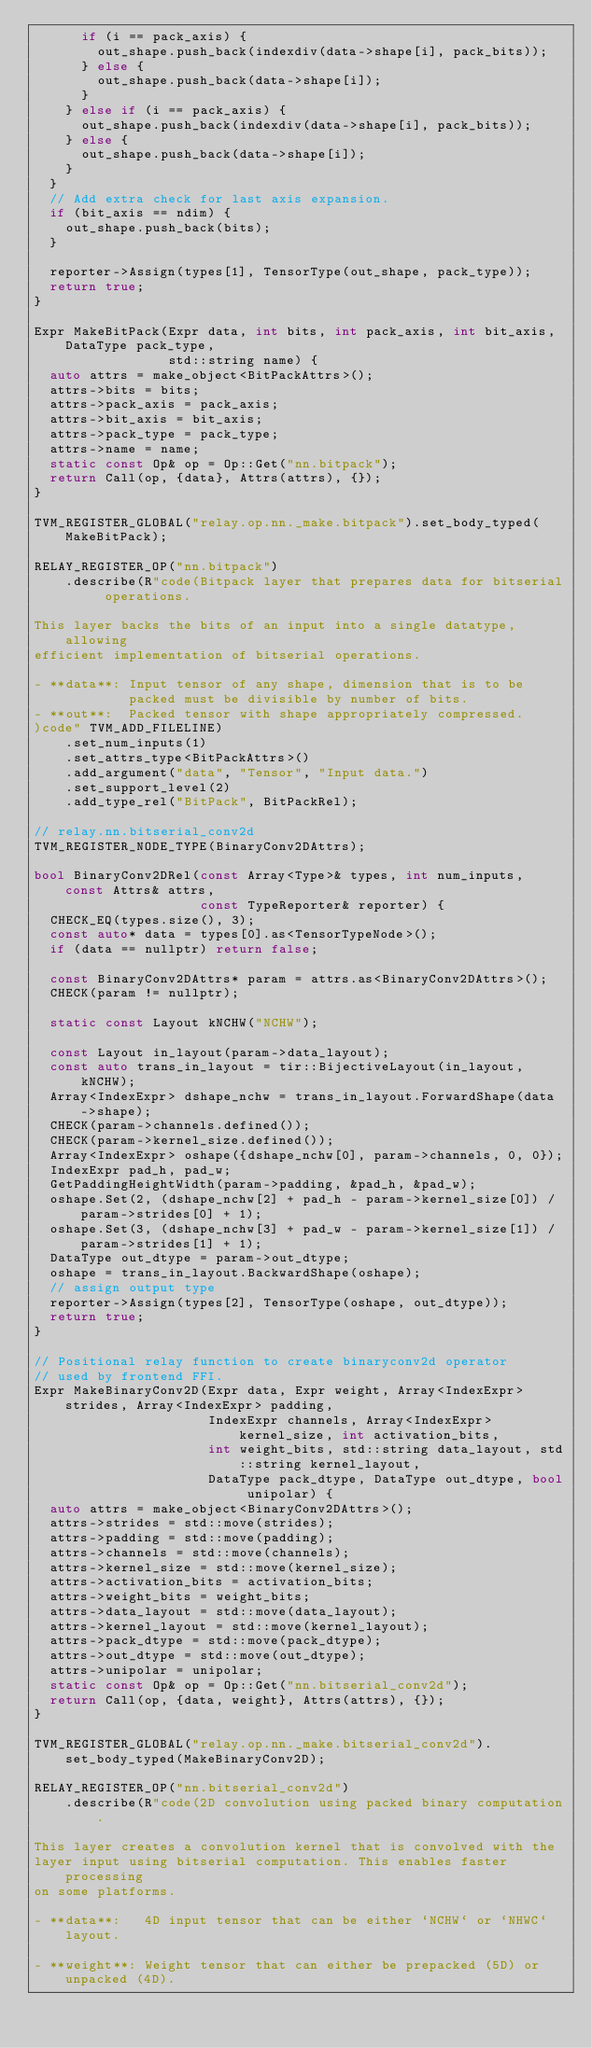<code> <loc_0><loc_0><loc_500><loc_500><_C++_>      if (i == pack_axis) {
        out_shape.push_back(indexdiv(data->shape[i], pack_bits));
      } else {
        out_shape.push_back(data->shape[i]);
      }
    } else if (i == pack_axis) {
      out_shape.push_back(indexdiv(data->shape[i], pack_bits));
    } else {
      out_shape.push_back(data->shape[i]);
    }
  }
  // Add extra check for last axis expansion.
  if (bit_axis == ndim) {
    out_shape.push_back(bits);
  }

  reporter->Assign(types[1], TensorType(out_shape, pack_type));
  return true;
}

Expr MakeBitPack(Expr data, int bits, int pack_axis, int bit_axis, DataType pack_type,
                 std::string name) {
  auto attrs = make_object<BitPackAttrs>();
  attrs->bits = bits;
  attrs->pack_axis = pack_axis;
  attrs->bit_axis = bit_axis;
  attrs->pack_type = pack_type;
  attrs->name = name;
  static const Op& op = Op::Get("nn.bitpack");
  return Call(op, {data}, Attrs(attrs), {});
}

TVM_REGISTER_GLOBAL("relay.op.nn._make.bitpack").set_body_typed(MakeBitPack);

RELAY_REGISTER_OP("nn.bitpack")
    .describe(R"code(Bitpack layer that prepares data for bitserial operations.

This layer backs the bits of an input into a single datatype, allowing
efficient implementation of bitserial operations.

- **data**: Input tensor of any shape, dimension that is to be
            packed must be divisible by number of bits.
- **out**:  Packed tensor with shape appropriately compressed.
)code" TVM_ADD_FILELINE)
    .set_num_inputs(1)
    .set_attrs_type<BitPackAttrs>()
    .add_argument("data", "Tensor", "Input data.")
    .set_support_level(2)
    .add_type_rel("BitPack", BitPackRel);

// relay.nn.bitserial_conv2d
TVM_REGISTER_NODE_TYPE(BinaryConv2DAttrs);

bool BinaryConv2DRel(const Array<Type>& types, int num_inputs, const Attrs& attrs,
                     const TypeReporter& reporter) {
  CHECK_EQ(types.size(), 3);
  const auto* data = types[0].as<TensorTypeNode>();
  if (data == nullptr) return false;

  const BinaryConv2DAttrs* param = attrs.as<BinaryConv2DAttrs>();
  CHECK(param != nullptr);

  static const Layout kNCHW("NCHW");

  const Layout in_layout(param->data_layout);
  const auto trans_in_layout = tir::BijectiveLayout(in_layout, kNCHW);
  Array<IndexExpr> dshape_nchw = trans_in_layout.ForwardShape(data->shape);
  CHECK(param->channels.defined());
  CHECK(param->kernel_size.defined());
  Array<IndexExpr> oshape({dshape_nchw[0], param->channels, 0, 0});
  IndexExpr pad_h, pad_w;
  GetPaddingHeightWidth(param->padding, &pad_h, &pad_w);
  oshape.Set(2, (dshape_nchw[2] + pad_h - param->kernel_size[0]) / param->strides[0] + 1);
  oshape.Set(3, (dshape_nchw[3] + pad_w - param->kernel_size[1]) / param->strides[1] + 1);
  DataType out_dtype = param->out_dtype;
  oshape = trans_in_layout.BackwardShape(oshape);
  // assign output type
  reporter->Assign(types[2], TensorType(oshape, out_dtype));
  return true;
}

// Positional relay function to create binaryconv2d operator
// used by frontend FFI.
Expr MakeBinaryConv2D(Expr data, Expr weight, Array<IndexExpr> strides, Array<IndexExpr> padding,
                      IndexExpr channels, Array<IndexExpr> kernel_size, int activation_bits,
                      int weight_bits, std::string data_layout, std::string kernel_layout,
                      DataType pack_dtype, DataType out_dtype, bool unipolar) {
  auto attrs = make_object<BinaryConv2DAttrs>();
  attrs->strides = std::move(strides);
  attrs->padding = std::move(padding);
  attrs->channels = std::move(channels);
  attrs->kernel_size = std::move(kernel_size);
  attrs->activation_bits = activation_bits;
  attrs->weight_bits = weight_bits;
  attrs->data_layout = std::move(data_layout);
  attrs->kernel_layout = std::move(kernel_layout);
  attrs->pack_dtype = std::move(pack_dtype);
  attrs->out_dtype = std::move(out_dtype);
  attrs->unipolar = unipolar;
  static const Op& op = Op::Get("nn.bitserial_conv2d");
  return Call(op, {data, weight}, Attrs(attrs), {});
}

TVM_REGISTER_GLOBAL("relay.op.nn._make.bitserial_conv2d").set_body_typed(MakeBinaryConv2D);

RELAY_REGISTER_OP("nn.bitserial_conv2d")
    .describe(R"code(2D convolution using packed binary computation.

This layer creates a convolution kernel that is convolved with the
layer input using bitserial computation. This enables faster processing
on some platforms.

- **data**:   4D input tensor that can be either `NCHW` or `NHWC` layout.

- **weight**: Weight tensor that can either be prepacked (5D) or unpacked (4D).</code> 